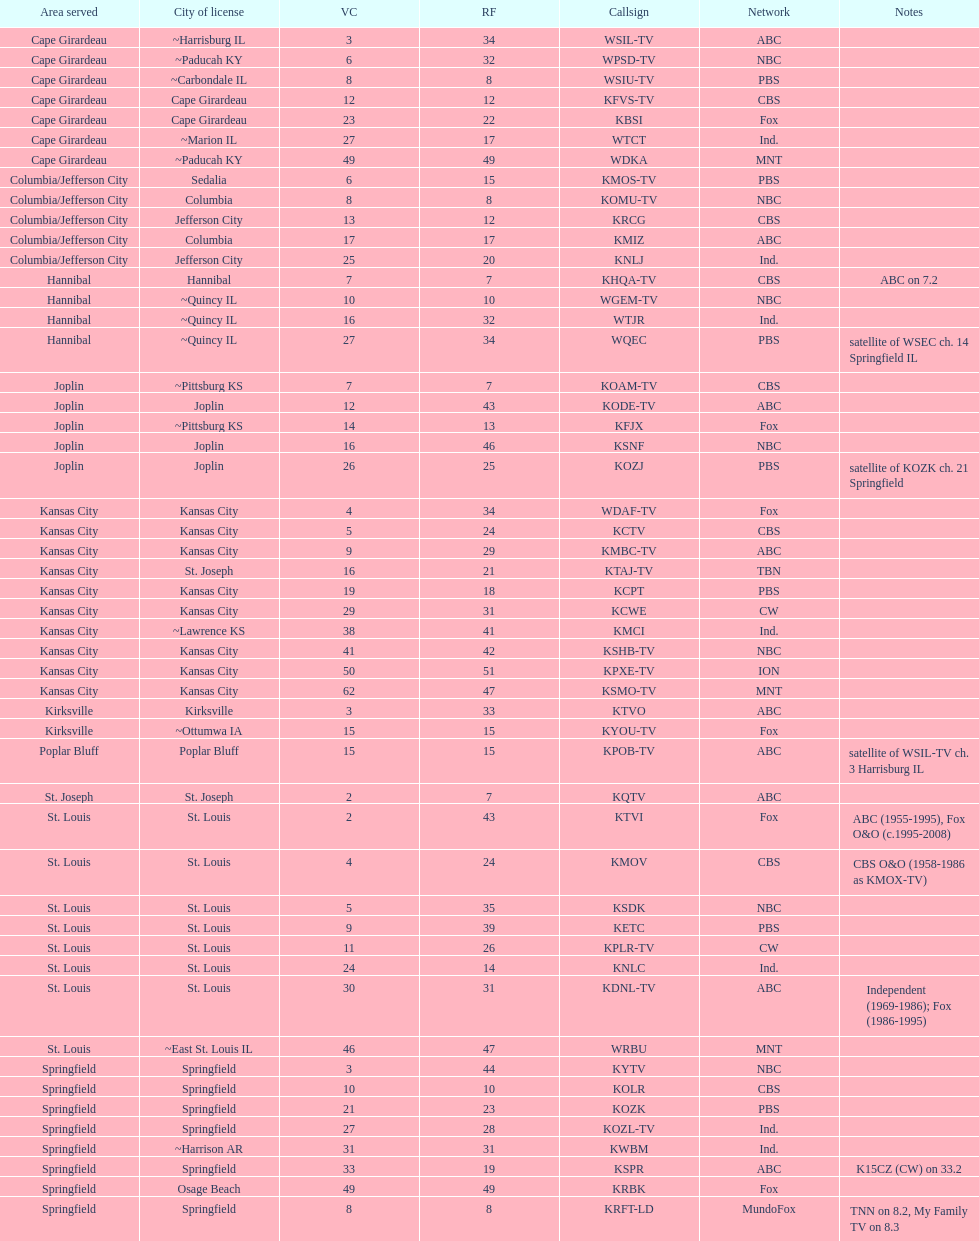How many television stations serve the cape girardeau area? 7. 